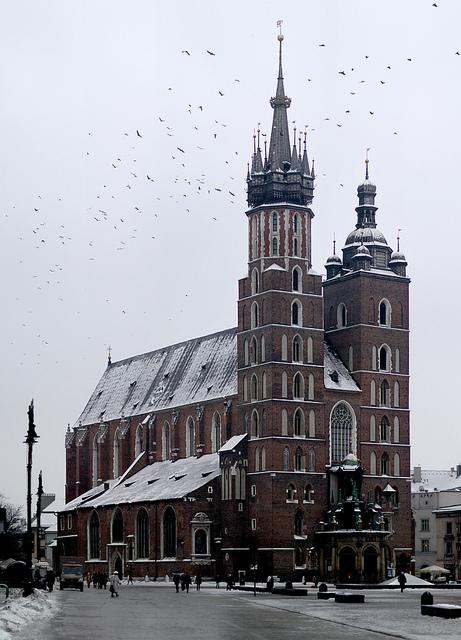What's the most likely season?
Concise answer only. Winter. Does this building have a clock?
Concise answer only. No. Can you see the full building?
Quick response, please. Yes. Are those flies?
Quick response, please. No. Is this a tower clock?
Quick response, please. No. What is in the sky?
Give a very brief answer. Birds. 